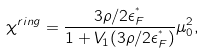Convert formula to latex. <formula><loc_0><loc_0><loc_500><loc_500>\chi ^ { r i n g } = \frac { 3 \rho / 2 \epsilon _ { F } ^ { ^ { * } } } { 1 + V _ { 1 } ( 3 \rho / 2 \epsilon _ { F } ^ { ^ { * } } ) } \mu _ { 0 } ^ { 2 } ,</formula> 